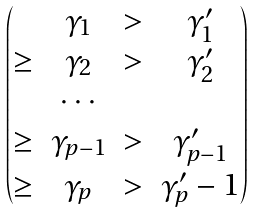Convert formula to latex. <formula><loc_0><loc_0><loc_500><loc_500>\begin{pmatrix} & \gamma _ { 1 } & > & \gamma ^ { \prime } _ { 1 } \\ \geq & \gamma _ { 2 } & > & \gamma ^ { \prime } _ { 2 } \\ & \cdots \\ \geq & \gamma _ { p - 1 } & > & \gamma ^ { \prime } _ { p - 1 } \\ \geq & \gamma _ { p } & > & \gamma ^ { \prime } _ { p } - 1 \end{pmatrix}</formula> 